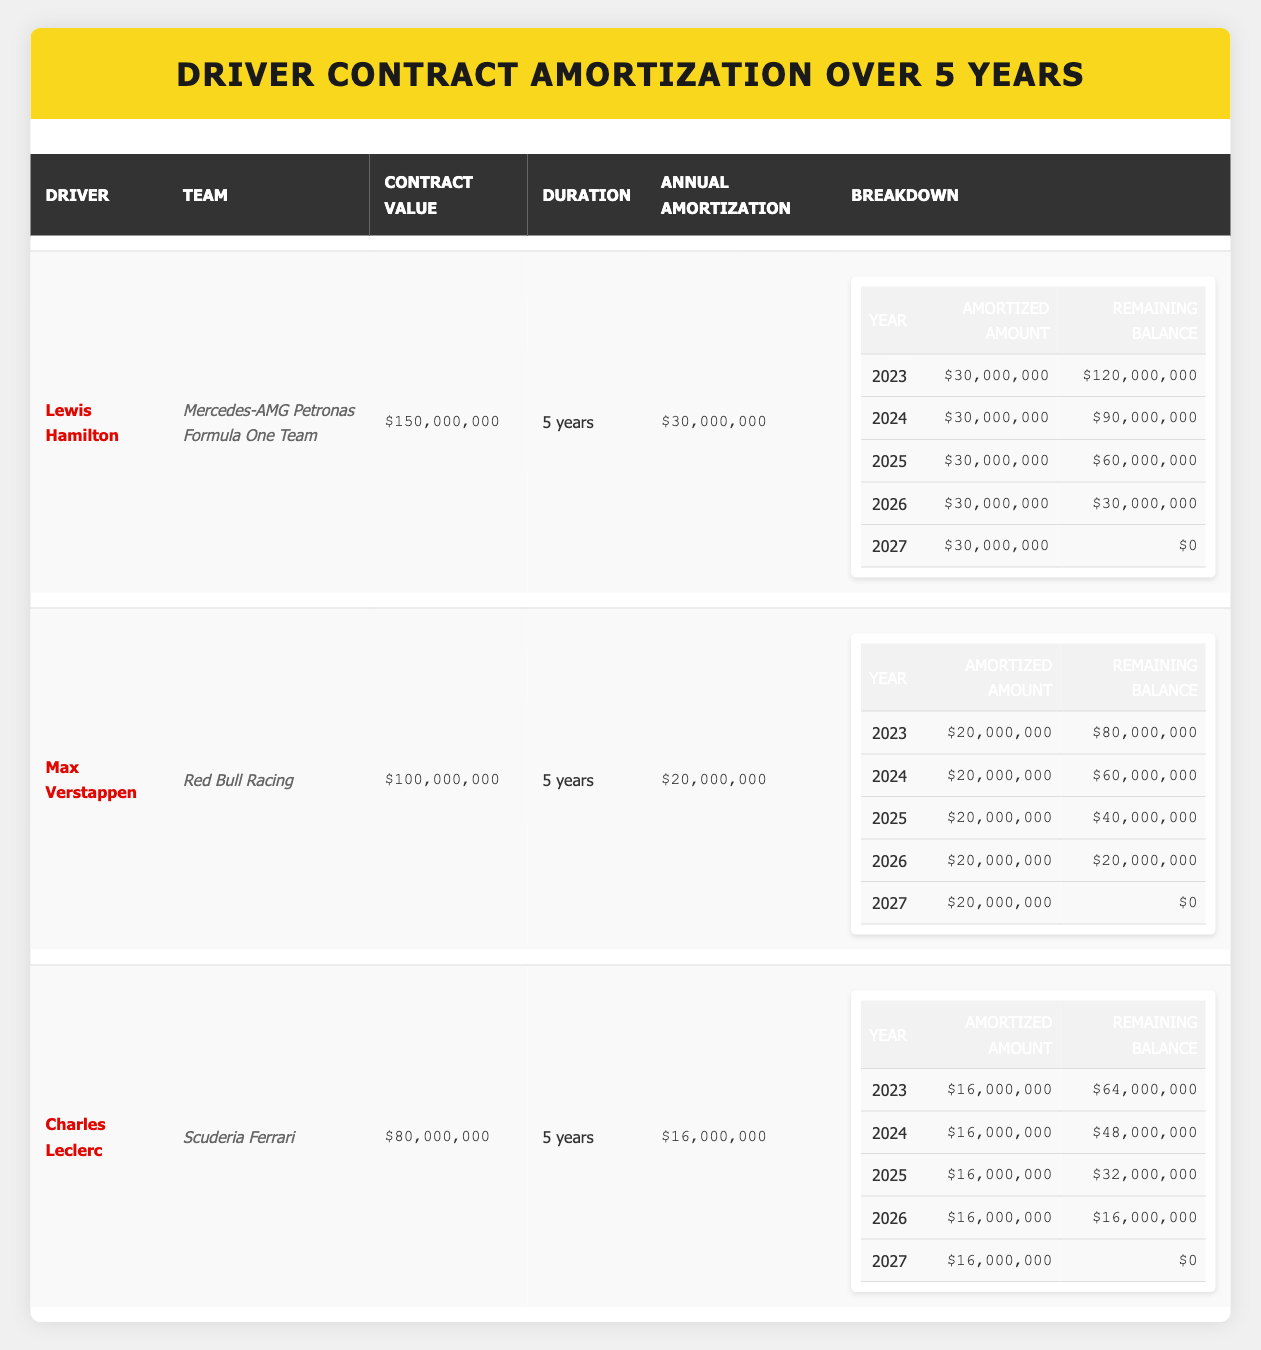What is the contract value for Lewis Hamilton? The contract value for Lewis Hamilton is listed directly in the table under the 'Contract Value' column, which shows $150,000,000.
Answer: $150,000,000 How much is the annual amortization for Max Verstappen? The annual amortization for Max Verstappen can be found in the 'Annual Amortization' column for his row, showing $20,000,000.
Answer: $20,000,000 Which driver has the lowest contract value? By comparing the 'Contract Value' column, Charles Leclerc has the lowest contract value at $80,000,000, which is lower than both Lewis Hamilton and Max Verstappen.
Answer: Charles Leclerc What is the remaining balance after the second year for Lewis Hamilton? In the breakdown for Lewis Hamilton, the 'Remaining Balance' column shows that after the second year (2024), the remaining balance is $90,000,000.
Answer: $90,000,000 How much total contractual value is amortized by the end of each year for Charles Leclerc? For Charles Leclerc, the total amortized amounts at the end of each year add up to: $16,000,000 (2023) + $16,000,000 (2024) + $16,000,000 (2025) + $16,000,000 (2026) + $16,000,000 (2027) = $80,000,000, which matches the total contract value.
Answer: $80,000,000 Is it true that all drivers will have a remaining balance of zero by the end of the contract duration? Yes, according to the 'Remaining Balance' column, all drivers, including Lewis Hamilton, Max Verstappen, and Charles Leclerc, have a remaining balance of $0 by the end of their contract duration (2027).
Answer: Yes Which driver has an annual amortization amount greater than $25,000,000? By reviewing the 'Annual Amortization' values, only Lewis Hamilton has an annual amortization amount of $30,000,000, which is greater than $25,000,000.
Answer: Lewis Hamilton What is the total amortized amount after 3 years for Max Verstappen? To calculate the total amortized amount for Max Verstappen after 3 years, we add the amortized amounts for each year: $20,000,000 (2023) + $20,000,000 (2024) + $20,000,000 (2025) = $60,000,000.
Answer: $60,000,000 In which year does Charles Leclerc's remaining balance first drop below $40,000,000? Charles Leclerc's remaining balance drops below $40,000,000 for the first time in the third year (2025), where the remaining balance shows $32,000,000.
Answer: 2025 